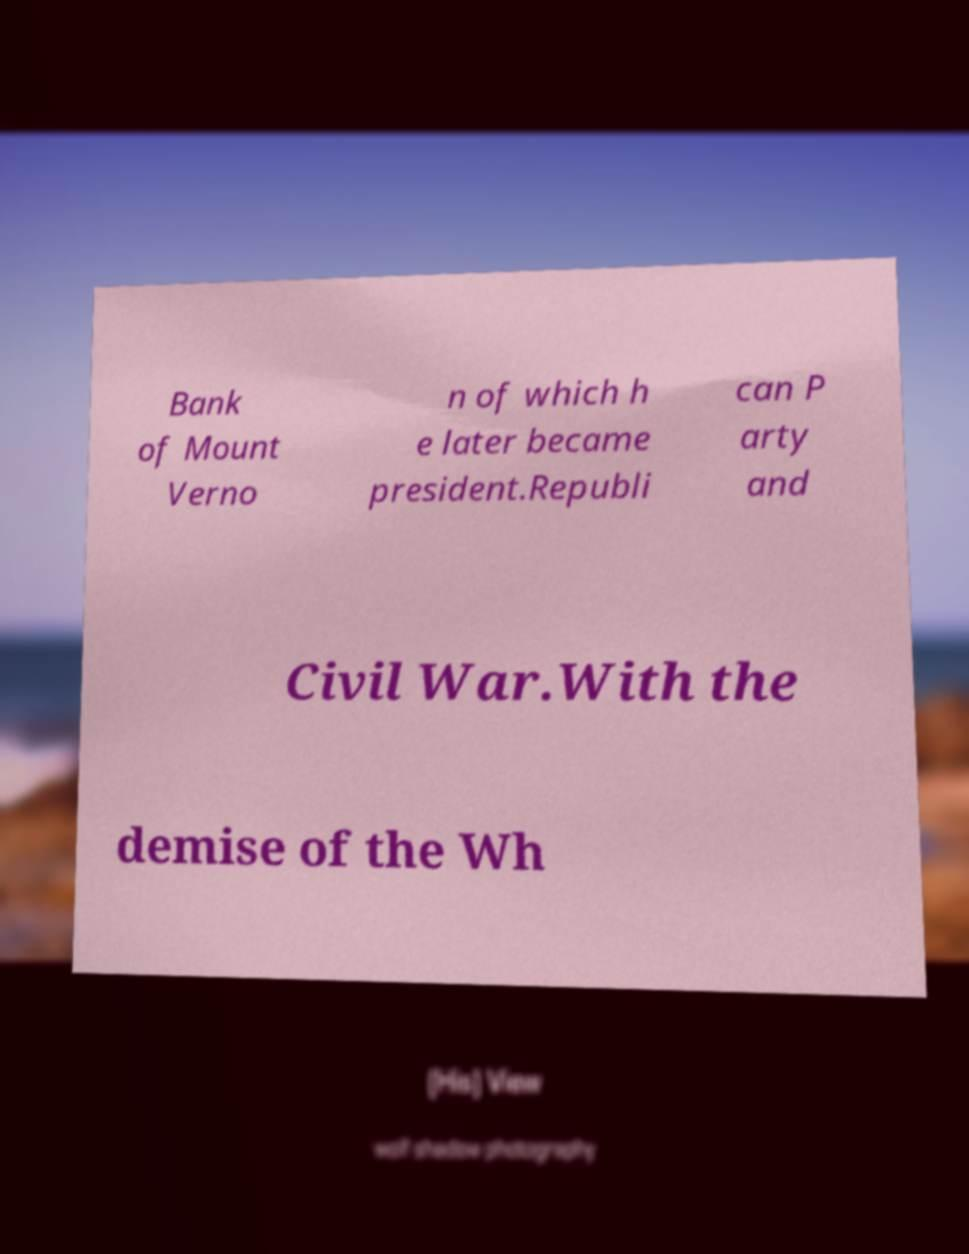What messages or text are displayed in this image? I need them in a readable, typed format. Bank of Mount Verno n of which h e later became president.Republi can P arty and Civil War.With the demise of the Wh 